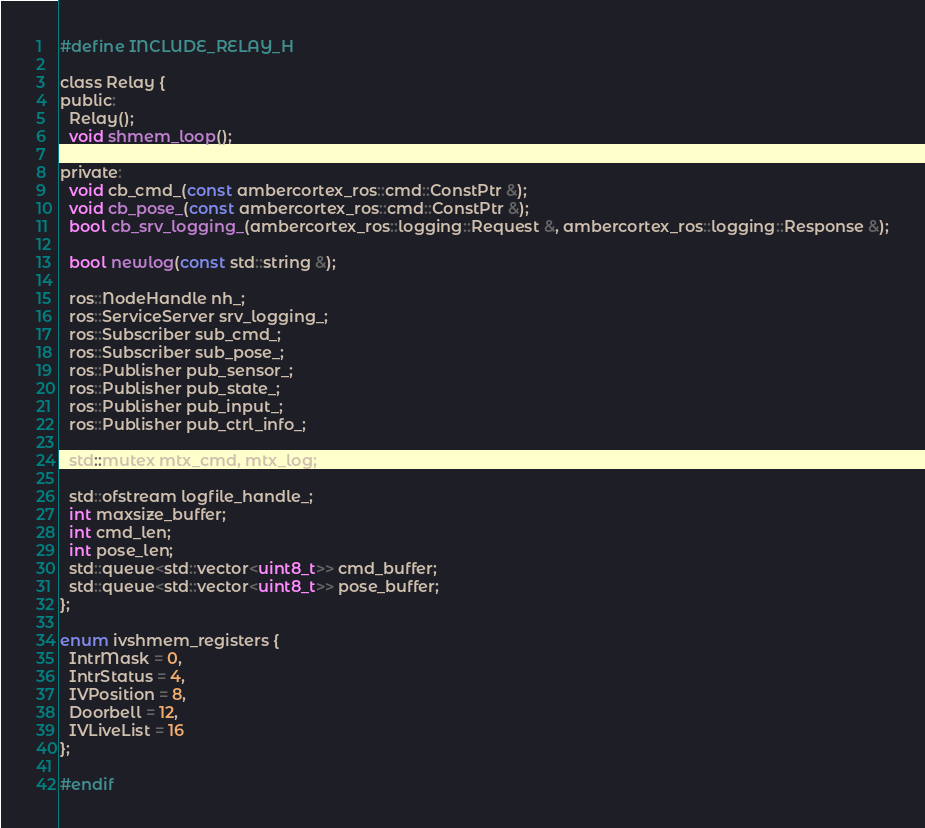Convert code to text. <code><loc_0><loc_0><loc_500><loc_500><_C_>#define INCLUDE_RELAY_H

class Relay {
public:
  Relay();
  void shmem_loop();

private:
  void cb_cmd_(const ambercortex_ros::cmd::ConstPtr &);
  void cb_pose_(const ambercortex_ros::cmd::ConstPtr &);
  bool cb_srv_logging_(ambercortex_ros::logging::Request &, ambercortex_ros::logging::Response &);

  bool newlog(const std::string &);

  ros::NodeHandle nh_;
  ros::ServiceServer srv_logging_;
  ros::Subscriber sub_cmd_;
  ros::Subscriber sub_pose_;
  ros::Publisher pub_sensor_;
  ros::Publisher pub_state_;
  ros::Publisher pub_input_;
  ros::Publisher pub_ctrl_info_;

  std::mutex mtx_cmd, mtx_log;

  std::ofstream logfile_handle_;
  int maxsize_buffer;
  int cmd_len;
  int pose_len;
  std::queue<std::vector<uint8_t>> cmd_buffer;
  std::queue<std::vector<uint8_t>> pose_buffer;
};

enum ivshmem_registers {
  IntrMask = 0,
  IntrStatus = 4,
  IVPosition = 8,
  Doorbell = 12,
  IVLiveList = 16
};

#endif
</code> 